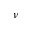<formula> <loc_0><loc_0><loc_500><loc_500>\nu</formula> 